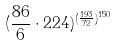Convert formula to latex. <formula><loc_0><loc_0><loc_500><loc_500>( \frac { 8 6 } { 6 } \cdot 2 2 4 ) ^ { ( \frac { 1 9 3 } { 7 2 } ) ^ { 1 5 0 } }</formula> 